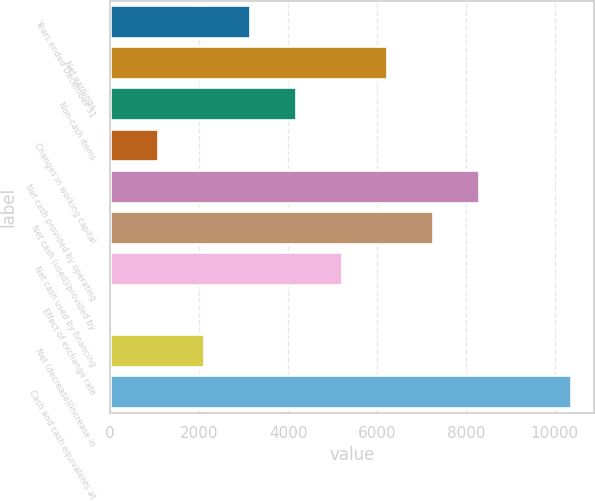<chart> <loc_0><loc_0><loc_500><loc_500><bar_chart><fcel>Years ended December 31<fcel>Net earnings<fcel>Non-cash items<fcel>Changes in working capital<fcel>Net cash provided by operating<fcel>Net cash (used)/provided by<fcel>Net cash used by financing<fcel>Effect of exchange rate<fcel>Net (decrease)/increase in<fcel>Cash and cash equivalents at<nl><fcel>3140.4<fcel>6234<fcel>4171.6<fcel>1078<fcel>8296.4<fcel>7265.2<fcel>5202.8<fcel>29<fcel>2109.2<fcel>10358.8<nl></chart> 